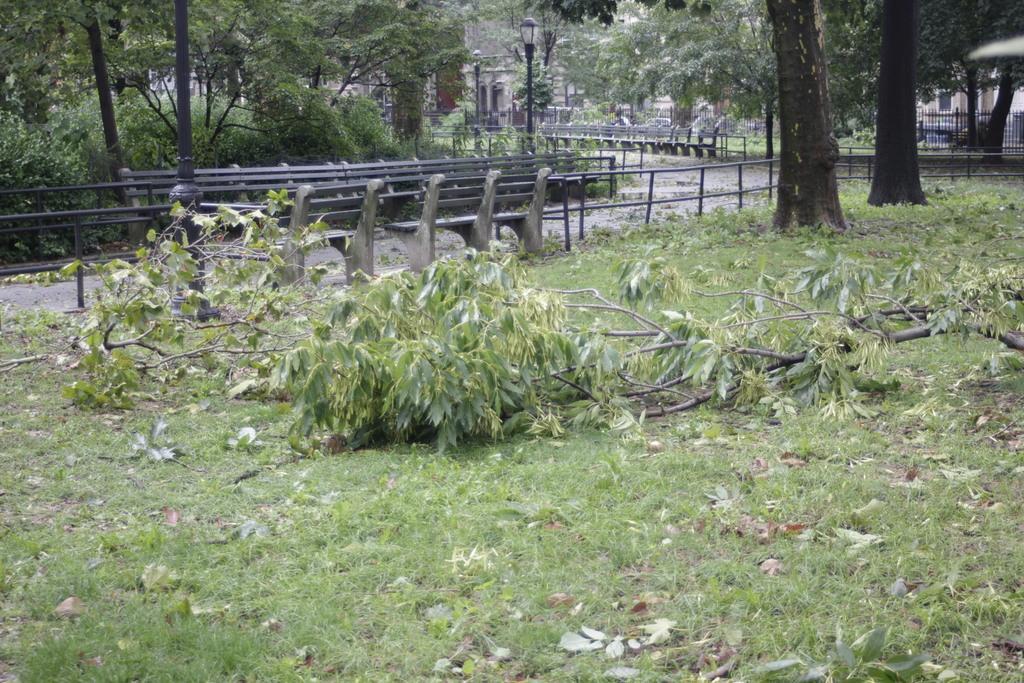In one or two sentences, can you explain what this image depicts? In this image we can see a branch of a tree on the grassy land. In the background, we can see benches, fence, pole, lights and trees. There are dry leaves on the land. 